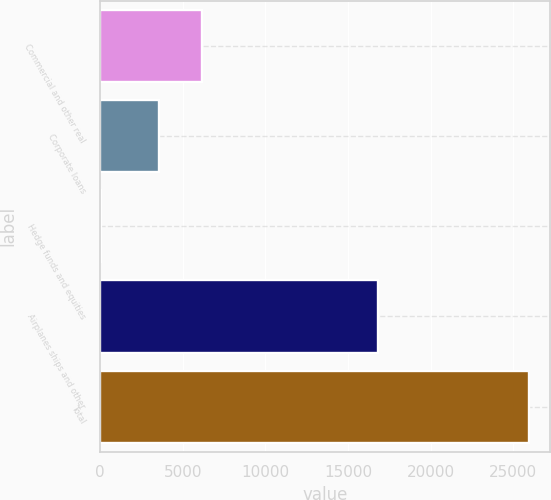<chart> <loc_0><loc_0><loc_500><loc_500><bar_chart><fcel>Commercial and other real<fcel>Corporate loans<fcel>Hedge funds and equities<fcel>Airplanes ships and other<fcel>Total<nl><fcel>6175.1<fcel>3587<fcel>58<fcel>16849<fcel>25939<nl></chart> 